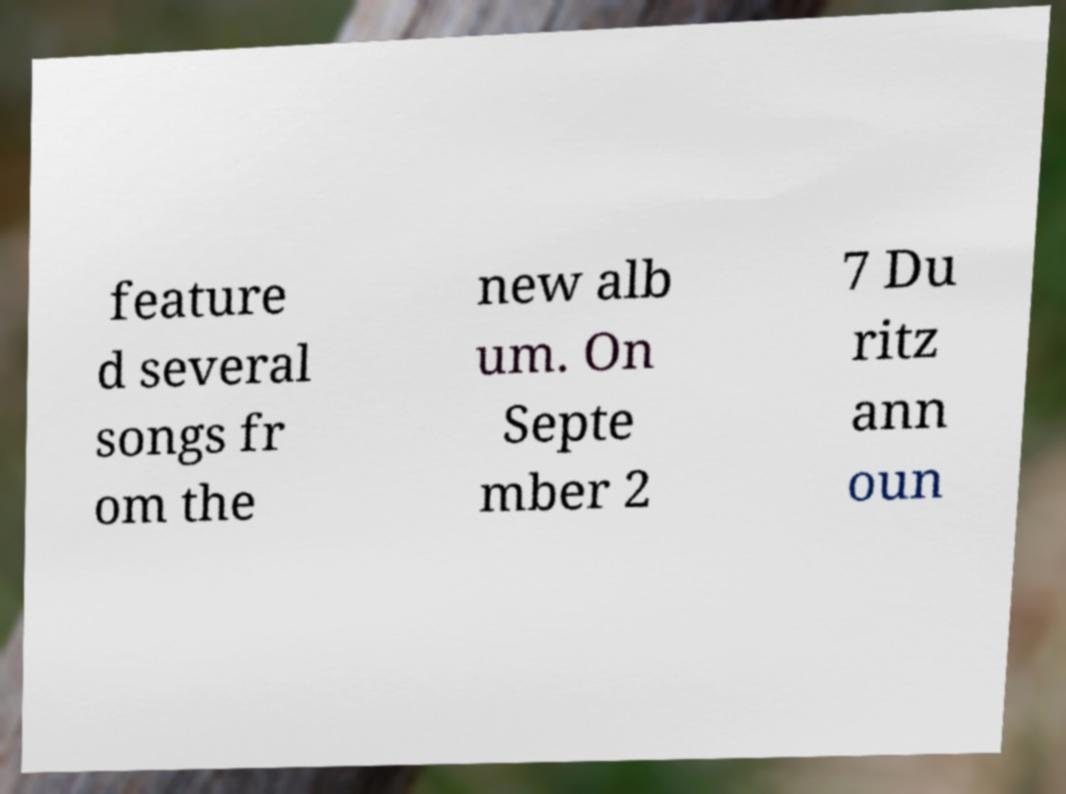Can you accurately transcribe the text from the provided image for me? feature d several songs fr om the new alb um. On Septe mber 2 7 Du ritz ann oun 